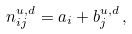<formula> <loc_0><loc_0><loc_500><loc_500>n _ { i j } ^ { u , d } = a _ { i } + b _ { j } ^ { u , d } \, ,</formula> 